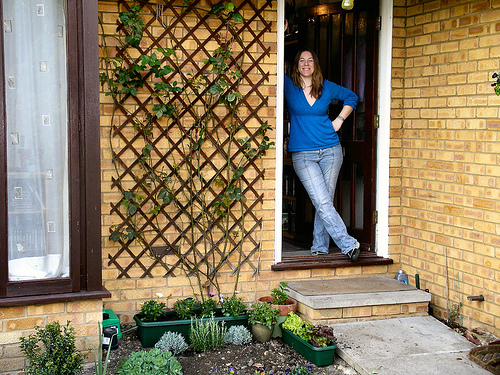<image>
Is the flower pot on the ground? Yes. Looking at the image, I can see the flower pot is positioned on top of the ground, with the ground providing support. 